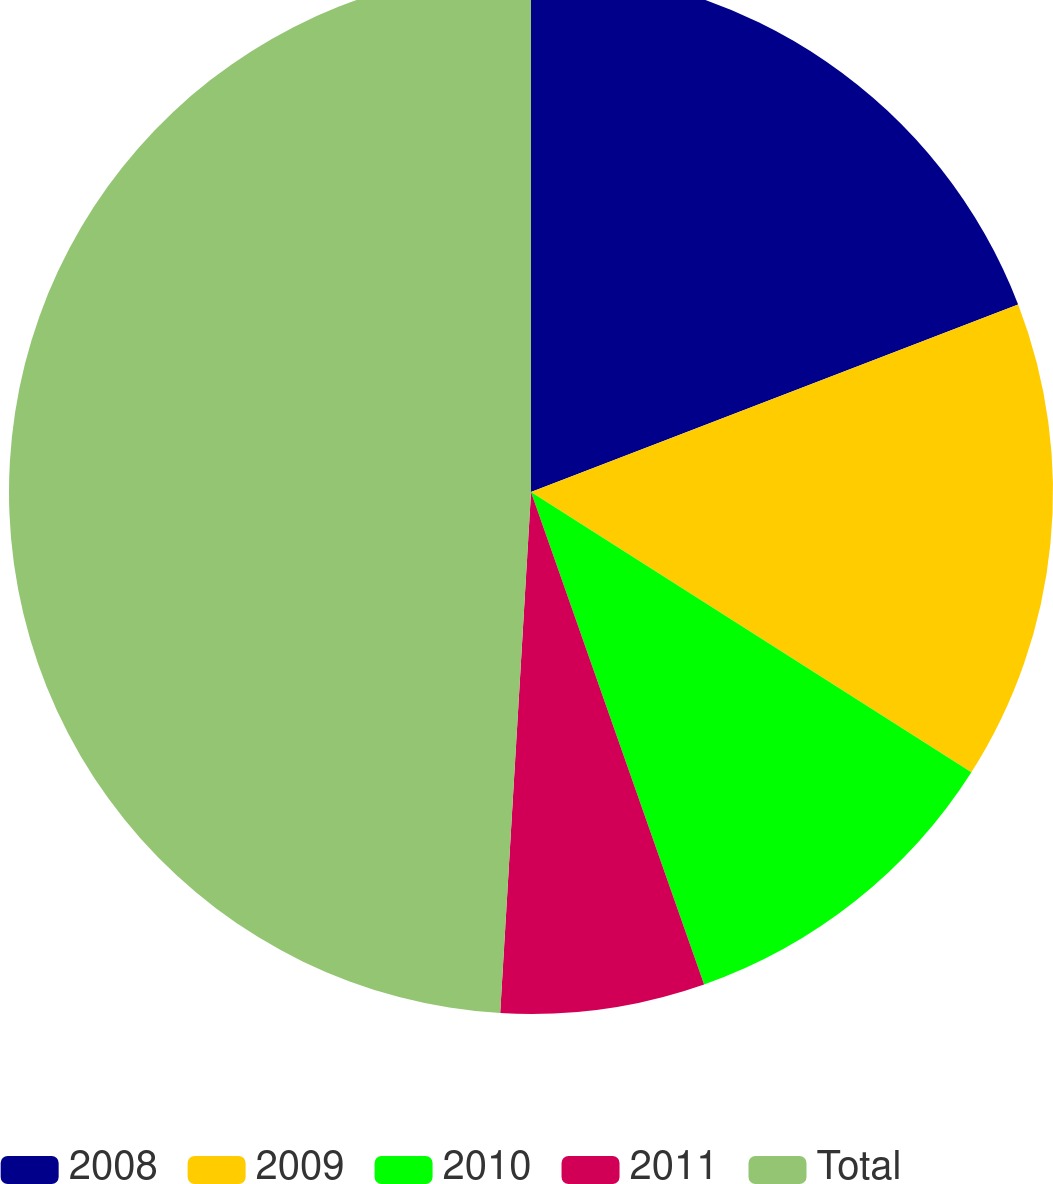Convert chart to OTSL. <chart><loc_0><loc_0><loc_500><loc_500><pie_chart><fcel>2008<fcel>2009<fcel>2010<fcel>2011<fcel>Total<nl><fcel>19.15%<fcel>14.87%<fcel>10.6%<fcel>6.32%<fcel>49.06%<nl></chart> 